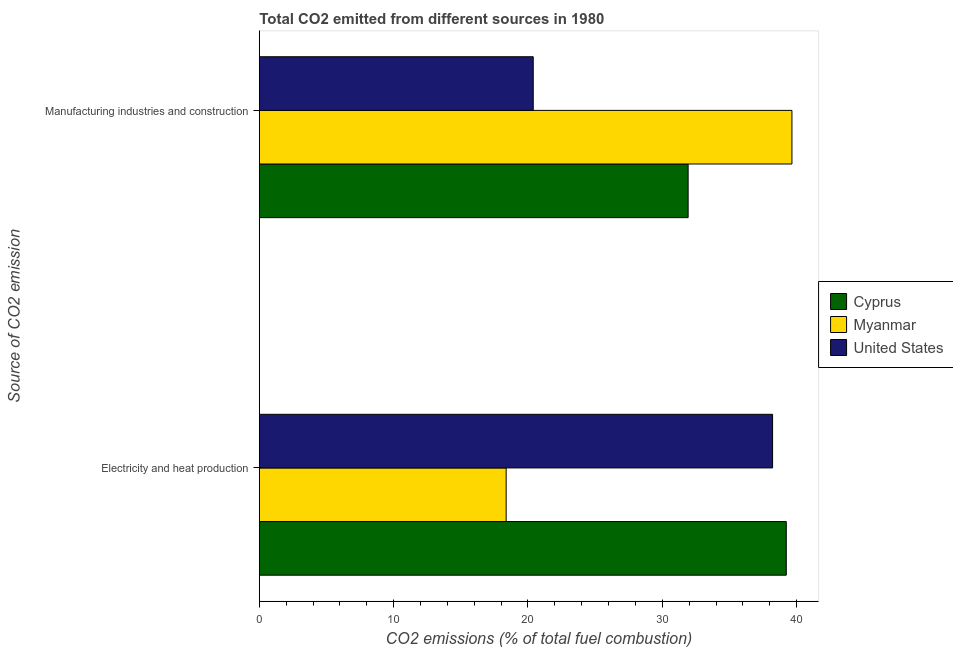How many different coloured bars are there?
Ensure brevity in your answer.  3. How many groups of bars are there?
Your answer should be compact. 2. How many bars are there on the 2nd tick from the bottom?
Provide a succinct answer. 3. What is the label of the 2nd group of bars from the top?
Provide a short and direct response. Electricity and heat production. What is the co2 emissions due to manufacturing industries in Myanmar?
Give a very brief answer. 39.65. Across all countries, what is the maximum co2 emissions due to electricity and heat production?
Keep it short and to the point. 39.23. Across all countries, what is the minimum co2 emissions due to electricity and heat production?
Ensure brevity in your answer.  18.38. In which country was the co2 emissions due to electricity and heat production maximum?
Give a very brief answer. Cyprus. In which country was the co2 emissions due to electricity and heat production minimum?
Give a very brief answer. Myanmar. What is the total co2 emissions due to manufacturing industries in the graph?
Offer a terse response. 91.97. What is the difference between the co2 emissions due to electricity and heat production in Cyprus and that in United States?
Offer a very short reply. 1.02. What is the difference between the co2 emissions due to manufacturing industries in United States and the co2 emissions due to electricity and heat production in Cyprus?
Provide a short and direct response. -18.84. What is the average co2 emissions due to electricity and heat production per country?
Your answer should be compact. 31.94. What is the difference between the co2 emissions due to electricity and heat production and co2 emissions due to manufacturing industries in Myanmar?
Give a very brief answer. -21.28. In how many countries, is the co2 emissions due to electricity and heat production greater than 36 %?
Your answer should be very brief. 2. What is the ratio of the co2 emissions due to electricity and heat production in Myanmar to that in United States?
Provide a short and direct response. 0.48. Is the co2 emissions due to manufacturing industries in Myanmar less than that in Cyprus?
Give a very brief answer. No. In how many countries, is the co2 emissions due to manufacturing industries greater than the average co2 emissions due to manufacturing industries taken over all countries?
Provide a short and direct response. 2. What does the 2nd bar from the top in Electricity and heat production represents?
Give a very brief answer. Myanmar. How many bars are there?
Ensure brevity in your answer.  6. Are all the bars in the graph horizontal?
Your response must be concise. Yes. Does the graph contain any zero values?
Ensure brevity in your answer.  No. Does the graph contain grids?
Your answer should be compact. No. How many legend labels are there?
Your answer should be compact. 3. What is the title of the graph?
Make the answer very short. Total CO2 emitted from different sources in 1980. What is the label or title of the X-axis?
Give a very brief answer. CO2 emissions (% of total fuel combustion). What is the label or title of the Y-axis?
Ensure brevity in your answer.  Source of CO2 emission. What is the CO2 emissions (% of total fuel combustion) in Cyprus in Electricity and heat production?
Keep it short and to the point. 39.23. What is the CO2 emissions (% of total fuel combustion) of Myanmar in Electricity and heat production?
Keep it short and to the point. 18.38. What is the CO2 emissions (% of total fuel combustion) in United States in Electricity and heat production?
Provide a short and direct response. 38.21. What is the CO2 emissions (% of total fuel combustion) in Cyprus in Manufacturing industries and construction?
Provide a short and direct response. 31.92. What is the CO2 emissions (% of total fuel combustion) in Myanmar in Manufacturing industries and construction?
Offer a terse response. 39.65. What is the CO2 emissions (% of total fuel combustion) in United States in Manufacturing industries and construction?
Your answer should be very brief. 20.39. Across all Source of CO2 emission, what is the maximum CO2 emissions (% of total fuel combustion) in Cyprus?
Keep it short and to the point. 39.23. Across all Source of CO2 emission, what is the maximum CO2 emissions (% of total fuel combustion) in Myanmar?
Your answer should be very brief. 39.65. Across all Source of CO2 emission, what is the maximum CO2 emissions (% of total fuel combustion) in United States?
Your answer should be compact. 38.21. Across all Source of CO2 emission, what is the minimum CO2 emissions (% of total fuel combustion) in Cyprus?
Provide a succinct answer. 31.92. Across all Source of CO2 emission, what is the minimum CO2 emissions (% of total fuel combustion) of Myanmar?
Keep it short and to the point. 18.38. Across all Source of CO2 emission, what is the minimum CO2 emissions (% of total fuel combustion) of United States?
Give a very brief answer. 20.39. What is the total CO2 emissions (% of total fuel combustion) of Cyprus in the graph?
Ensure brevity in your answer.  71.15. What is the total CO2 emissions (% of total fuel combustion) in Myanmar in the graph?
Offer a very short reply. 58.03. What is the total CO2 emissions (% of total fuel combustion) of United States in the graph?
Ensure brevity in your answer.  58.6. What is the difference between the CO2 emissions (% of total fuel combustion) of Cyprus in Electricity and heat production and that in Manufacturing industries and construction?
Keep it short and to the point. 7.31. What is the difference between the CO2 emissions (% of total fuel combustion) of Myanmar in Electricity and heat production and that in Manufacturing industries and construction?
Your answer should be very brief. -21.28. What is the difference between the CO2 emissions (% of total fuel combustion) in United States in Electricity and heat production and that in Manufacturing industries and construction?
Offer a very short reply. 17.82. What is the difference between the CO2 emissions (% of total fuel combustion) in Cyprus in Electricity and heat production and the CO2 emissions (% of total fuel combustion) in Myanmar in Manufacturing industries and construction?
Provide a succinct answer. -0.42. What is the difference between the CO2 emissions (% of total fuel combustion) of Cyprus in Electricity and heat production and the CO2 emissions (% of total fuel combustion) of United States in Manufacturing industries and construction?
Keep it short and to the point. 18.84. What is the difference between the CO2 emissions (% of total fuel combustion) in Myanmar in Electricity and heat production and the CO2 emissions (% of total fuel combustion) in United States in Manufacturing industries and construction?
Offer a terse response. -2.02. What is the average CO2 emissions (% of total fuel combustion) of Cyprus per Source of CO2 emission?
Your answer should be compact. 35.58. What is the average CO2 emissions (% of total fuel combustion) in Myanmar per Source of CO2 emission?
Give a very brief answer. 29.01. What is the average CO2 emissions (% of total fuel combustion) of United States per Source of CO2 emission?
Keep it short and to the point. 29.3. What is the difference between the CO2 emissions (% of total fuel combustion) in Cyprus and CO2 emissions (% of total fuel combustion) in Myanmar in Electricity and heat production?
Offer a terse response. 20.86. What is the difference between the CO2 emissions (% of total fuel combustion) in Cyprus and CO2 emissions (% of total fuel combustion) in United States in Electricity and heat production?
Provide a short and direct response. 1.02. What is the difference between the CO2 emissions (% of total fuel combustion) in Myanmar and CO2 emissions (% of total fuel combustion) in United States in Electricity and heat production?
Make the answer very short. -19.84. What is the difference between the CO2 emissions (% of total fuel combustion) of Cyprus and CO2 emissions (% of total fuel combustion) of Myanmar in Manufacturing industries and construction?
Ensure brevity in your answer.  -7.73. What is the difference between the CO2 emissions (% of total fuel combustion) of Cyprus and CO2 emissions (% of total fuel combustion) of United States in Manufacturing industries and construction?
Offer a terse response. 11.53. What is the difference between the CO2 emissions (% of total fuel combustion) of Myanmar and CO2 emissions (% of total fuel combustion) of United States in Manufacturing industries and construction?
Keep it short and to the point. 19.26. What is the ratio of the CO2 emissions (% of total fuel combustion) in Cyprus in Electricity and heat production to that in Manufacturing industries and construction?
Make the answer very short. 1.23. What is the ratio of the CO2 emissions (% of total fuel combustion) of Myanmar in Electricity and heat production to that in Manufacturing industries and construction?
Your response must be concise. 0.46. What is the ratio of the CO2 emissions (% of total fuel combustion) in United States in Electricity and heat production to that in Manufacturing industries and construction?
Your answer should be very brief. 1.87. What is the difference between the highest and the second highest CO2 emissions (% of total fuel combustion) of Cyprus?
Make the answer very short. 7.31. What is the difference between the highest and the second highest CO2 emissions (% of total fuel combustion) of Myanmar?
Provide a short and direct response. 21.28. What is the difference between the highest and the second highest CO2 emissions (% of total fuel combustion) of United States?
Give a very brief answer. 17.82. What is the difference between the highest and the lowest CO2 emissions (% of total fuel combustion) in Cyprus?
Ensure brevity in your answer.  7.31. What is the difference between the highest and the lowest CO2 emissions (% of total fuel combustion) in Myanmar?
Provide a short and direct response. 21.28. What is the difference between the highest and the lowest CO2 emissions (% of total fuel combustion) in United States?
Keep it short and to the point. 17.82. 